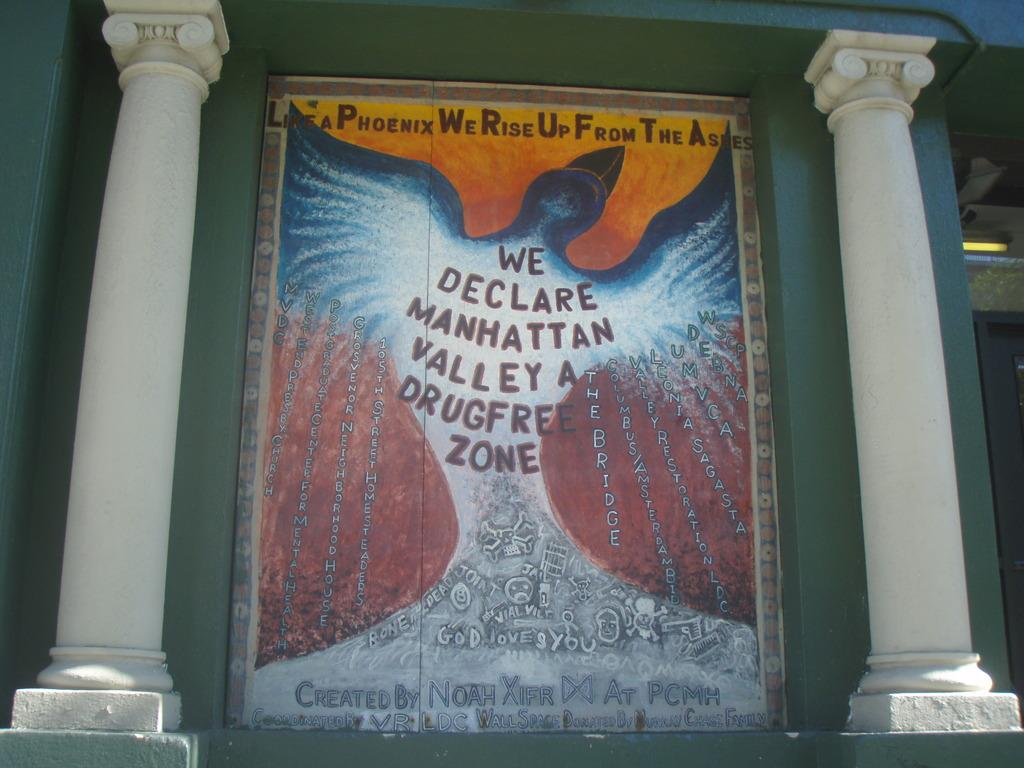<image>
Write a terse but informative summary of the picture. Wall art that was created by Noah Xifr advertising drug free zone. 